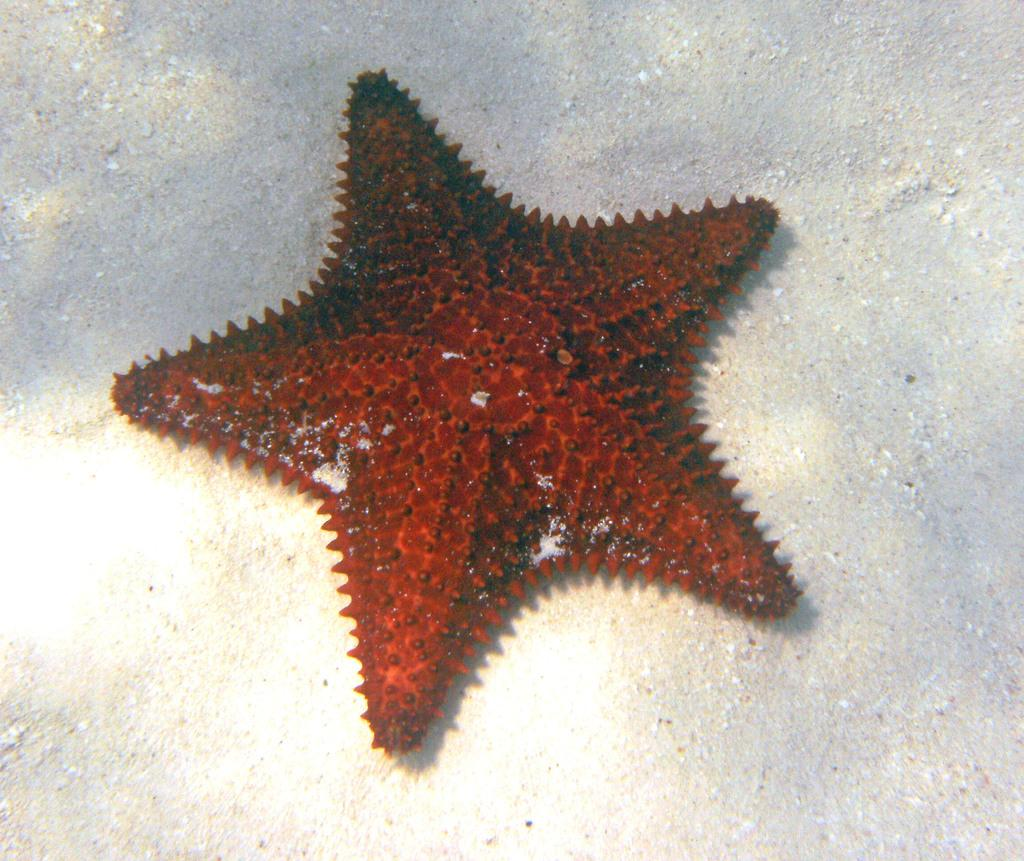What type of sea creature is in the image? There is a starfish in the image. Where is the starfish located? The starfish is on the surface. What type of sweater is the starfish wearing in the image? There is no sweater present in the image, as starfish do not wear clothing. 